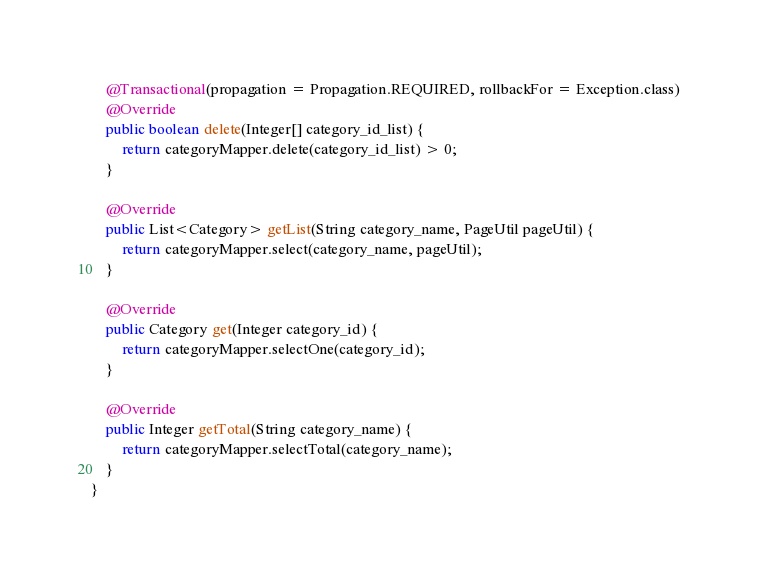<code> <loc_0><loc_0><loc_500><loc_500><_Java_>
    @Transactional(propagation = Propagation.REQUIRED, rollbackFor = Exception.class)
    @Override
    public boolean delete(Integer[] category_id_list) {
        return categoryMapper.delete(category_id_list) > 0;
    }

    @Override
    public List<Category> getList(String category_name, PageUtil pageUtil) {
        return categoryMapper.select(category_name, pageUtil);
    }

    @Override
    public Category get(Integer category_id) {
        return categoryMapper.selectOne(category_id);
    }

    @Override
    public Integer getTotal(String category_name) {
        return categoryMapper.selectTotal(category_name);
    }
}
</code> 